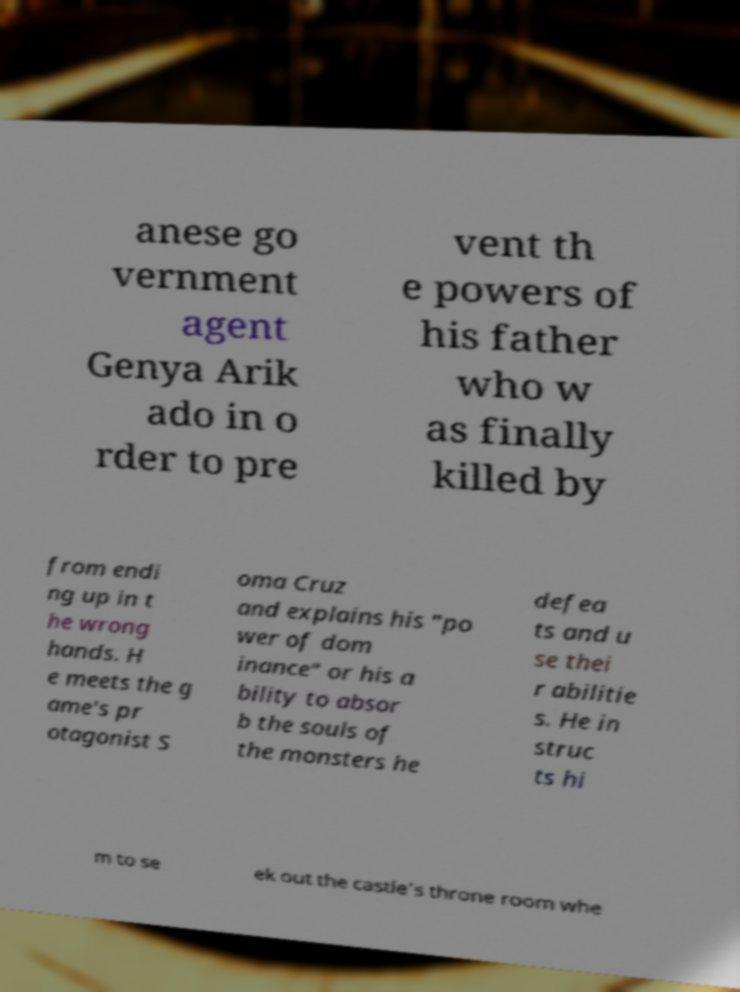Can you accurately transcribe the text from the provided image for me? anese go vernment agent Genya Arik ado in o rder to pre vent th e powers of his father who w as finally killed by from endi ng up in t he wrong hands. H e meets the g ame's pr otagonist S oma Cruz and explains his "po wer of dom inance" or his a bility to absor b the souls of the monsters he defea ts and u se thei r abilitie s. He in struc ts hi m to se ek out the castle's throne room whe 